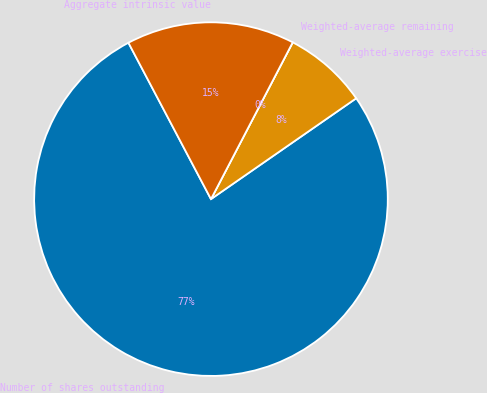Convert chart to OTSL. <chart><loc_0><loc_0><loc_500><loc_500><pie_chart><fcel>Number of shares outstanding<fcel>Weighted-average exercise<fcel>Weighted-average remaining<fcel>Aggregate intrinsic value<nl><fcel>76.92%<fcel>7.69%<fcel>0.0%<fcel>15.38%<nl></chart> 